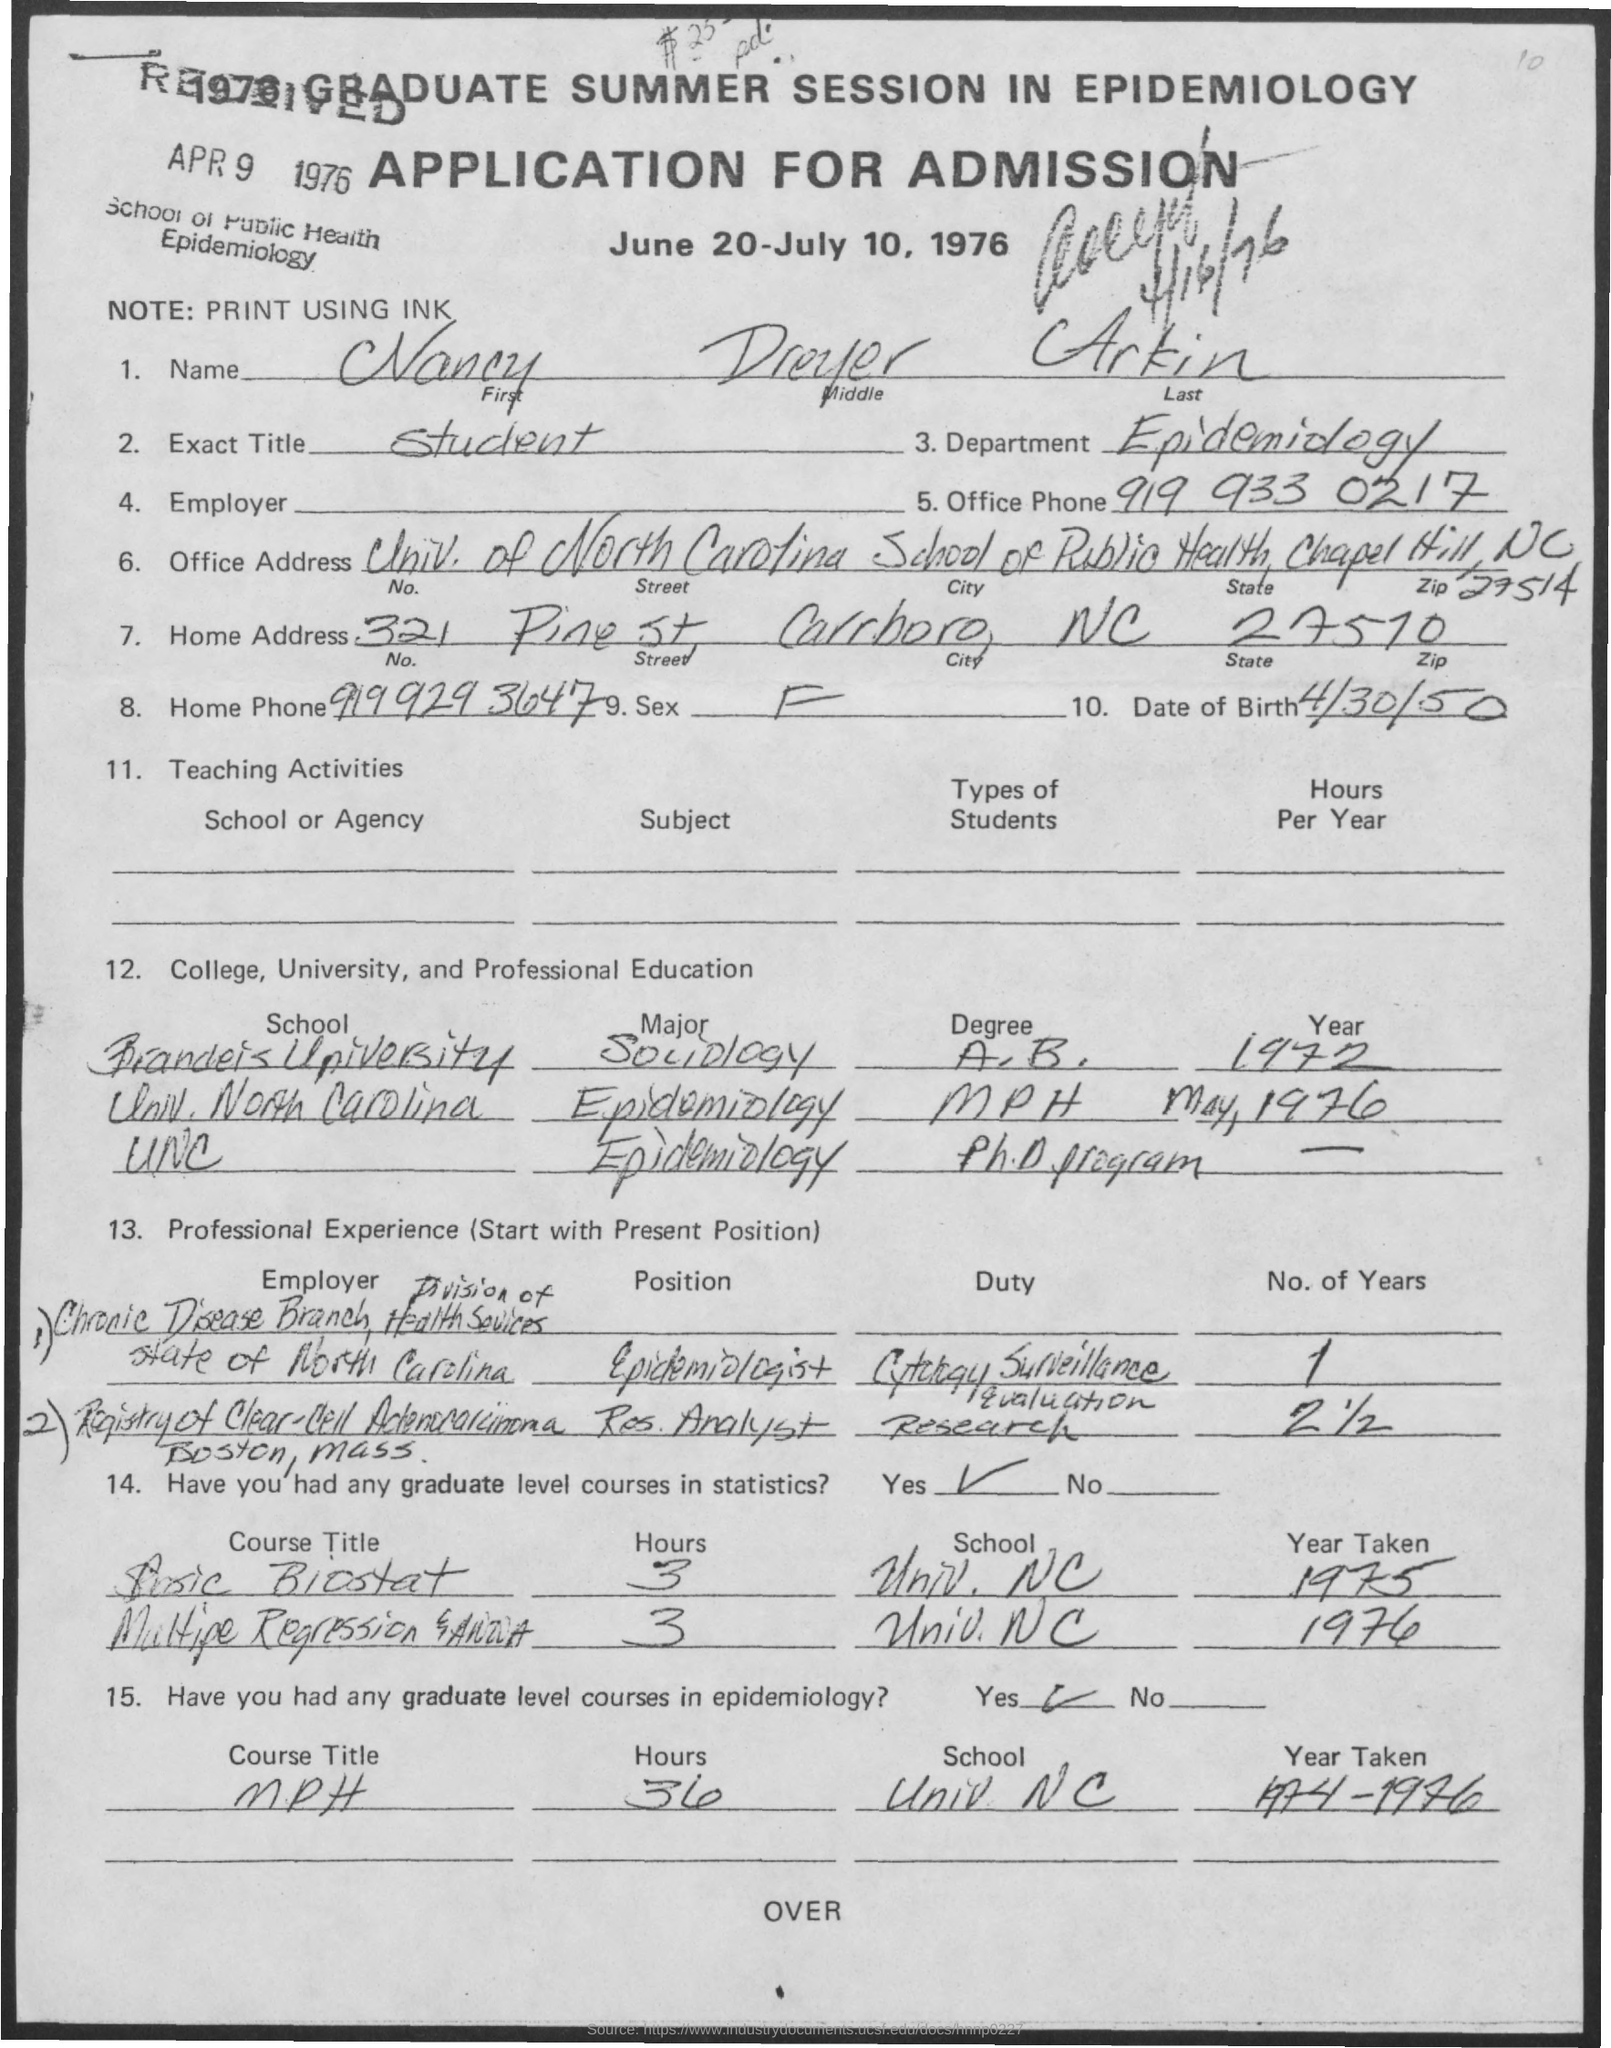List a handful of essential elements in this visual. I am looking for the phone number of the office, which is 919 933 0217. The individual seeking information has asked, 'What is the home phone number?' The phone number provided is 9199293647. What is the date of birth?" is a question that requires a response. The speaker is inquiring about the department to which a person belongs in relation to epidemiology. I, being a student, desire to know the exact title of the object of my query. 